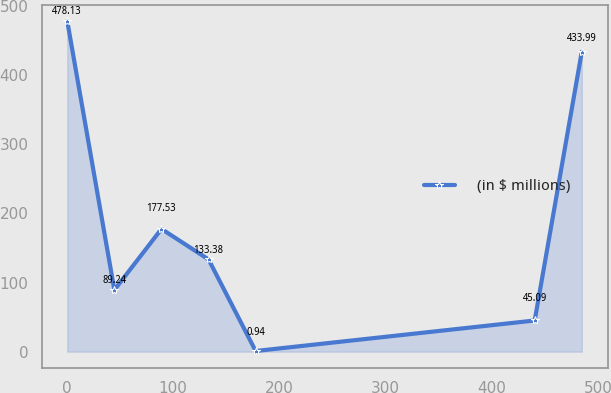Convert chart. <chart><loc_0><loc_0><loc_500><loc_500><line_chart><ecel><fcel>(in $ millions)<nl><fcel>0.86<fcel>478.13<nl><fcel>45.16<fcel>89.24<nl><fcel>89.46<fcel>177.53<nl><fcel>133.76<fcel>133.38<nl><fcel>178.06<fcel>0.94<nl><fcel>440.55<fcel>45.09<nl><fcel>484.85<fcel>433.99<nl></chart> 